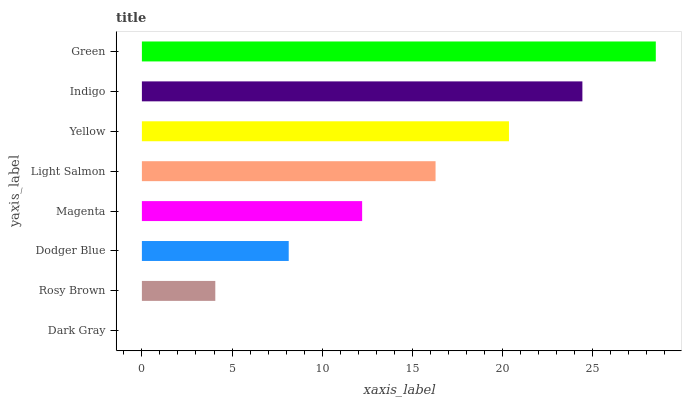Is Dark Gray the minimum?
Answer yes or no. Yes. Is Green the maximum?
Answer yes or no. Yes. Is Rosy Brown the minimum?
Answer yes or no. No. Is Rosy Brown the maximum?
Answer yes or no. No. Is Rosy Brown greater than Dark Gray?
Answer yes or no. Yes. Is Dark Gray less than Rosy Brown?
Answer yes or no. Yes. Is Dark Gray greater than Rosy Brown?
Answer yes or no. No. Is Rosy Brown less than Dark Gray?
Answer yes or no. No. Is Light Salmon the high median?
Answer yes or no. Yes. Is Magenta the low median?
Answer yes or no. Yes. Is Rosy Brown the high median?
Answer yes or no. No. Is Indigo the low median?
Answer yes or no. No. 